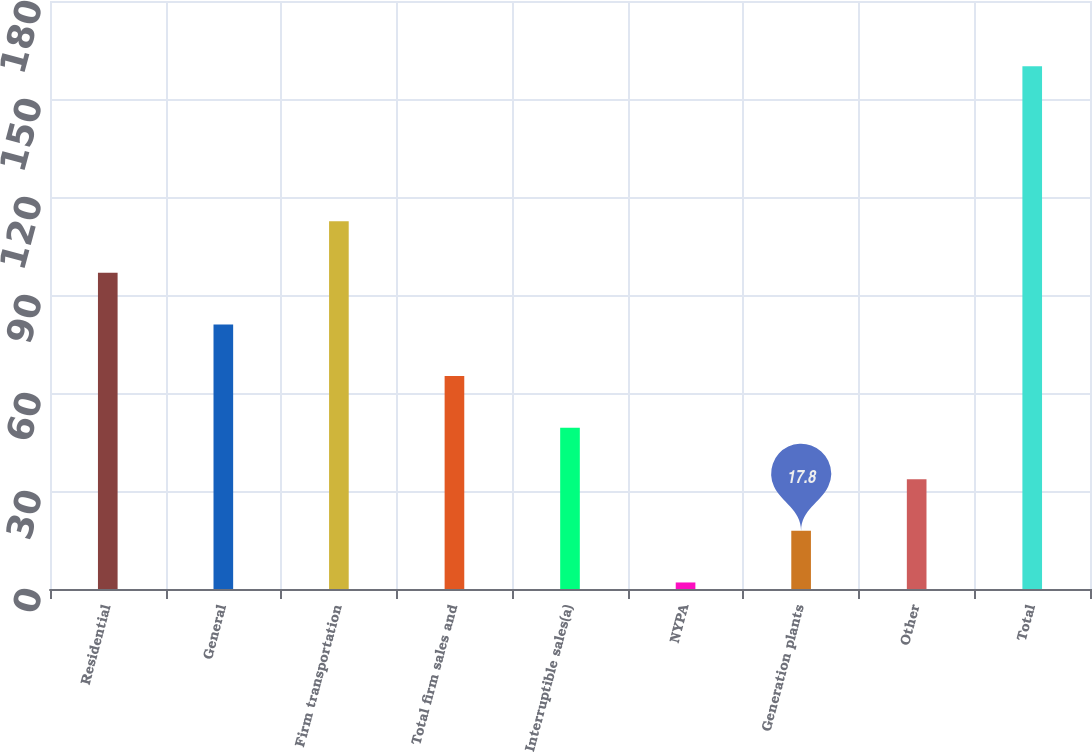<chart> <loc_0><loc_0><loc_500><loc_500><bar_chart><fcel>Residential<fcel>General<fcel>Firm transportation<fcel>Total firm sales and<fcel>Interruptible sales(a)<fcel>NYPA<fcel>Generation plants<fcel>Other<fcel>Total<nl><fcel>96.8<fcel>81<fcel>112.6<fcel>65.2<fcel>49.4<fcel>2<fcel>17.8<fcel>33.6<fcel>160<nl></chart> 